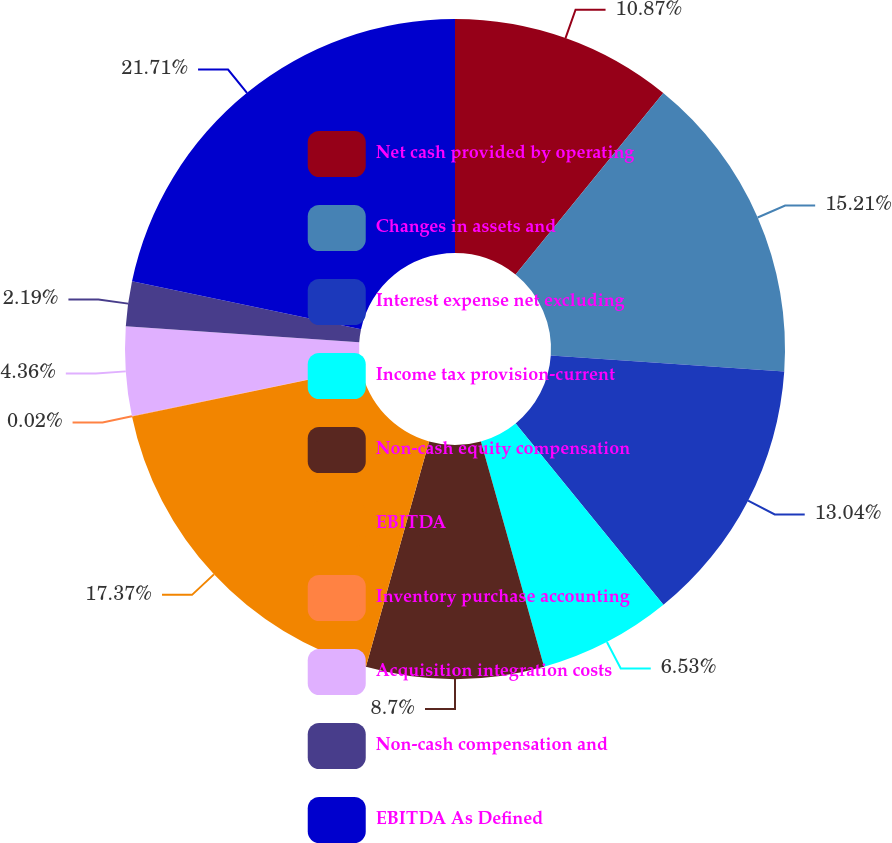<chart> <loc_0><loc_0><loc_500><loc_500><pie_chart><fcel>Net cash provided by operating<fcel>Changes in assets and<fcel>Interest expense net excluding<fcel>Income tax provision-current<fcel>Non-cash equity compensation<fcel>EBITDA<fcel>Inventory purchase accounting<fcel>Acquisition integration costs<fcel>Non-cash compensation and<fcel>EBITDA As Defined<nl><fcel>10.87%<fcel>15.21%<fcel>13.04%<fcel>6.53%<fcel>8.7%<fcel>17.37%<fcel>0.02%<fcel>4.36%<fcel>2.19%<fcel>21.71%<nl></chart> 